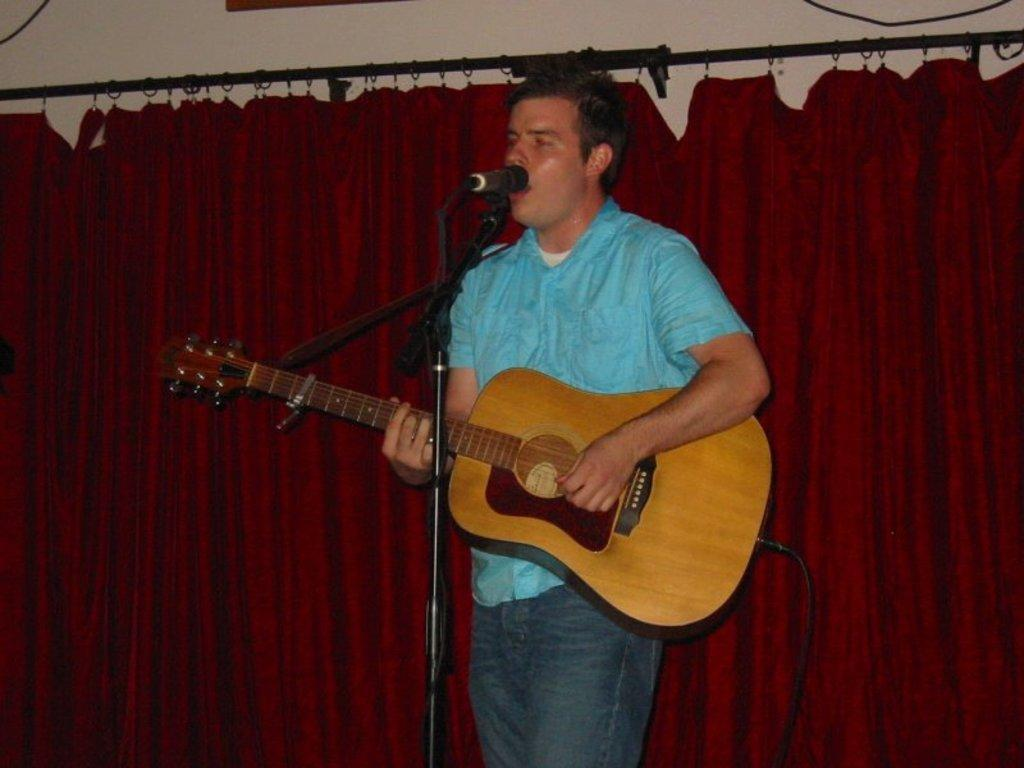What is the man in the image doing? The man is playing a guitar. What is the man's position in the image? The man is standing. What object is the man in front of? The man is in front of a microphone. What can be seen in the background of the image? There is a curtain in the background of the image. What is the color of the curtain? The curtain is maroon in color. How many tin snails are hanging from the icicle in the image? There are no tin snails or icicles present in the image. 